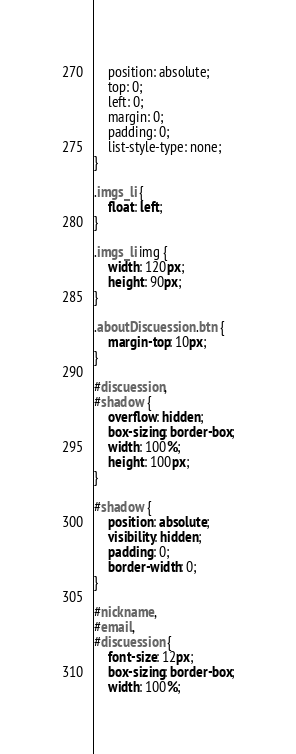<code> <loc_0><loc_0><loc_500><loc_500><_CSS_>    position: absolute;
    top: 0;
    left: 0;
    margin: 0;
    padding: 0;
    list-style-type: none;
}

.imgs_li {
    float: left;
}

.imgs_li img {
    width: 120px;
    height: 90px;
}

.aboutDiscuession .btn {
    margin-top: 10px;
}

#discuession,
#shadow {
    overflow: hidden;
    box-sizing: border-box;
    width: 100%;
    height: 100px;
}

#shadow {
    position: absolute;
    visibility: hidden;
    padding: 0;
    border-width: 0;
}

#nickname,
#email,
#discuession {
    font-size: 12px;
    box-sizing: border-box;
    width: 100%;</code> 